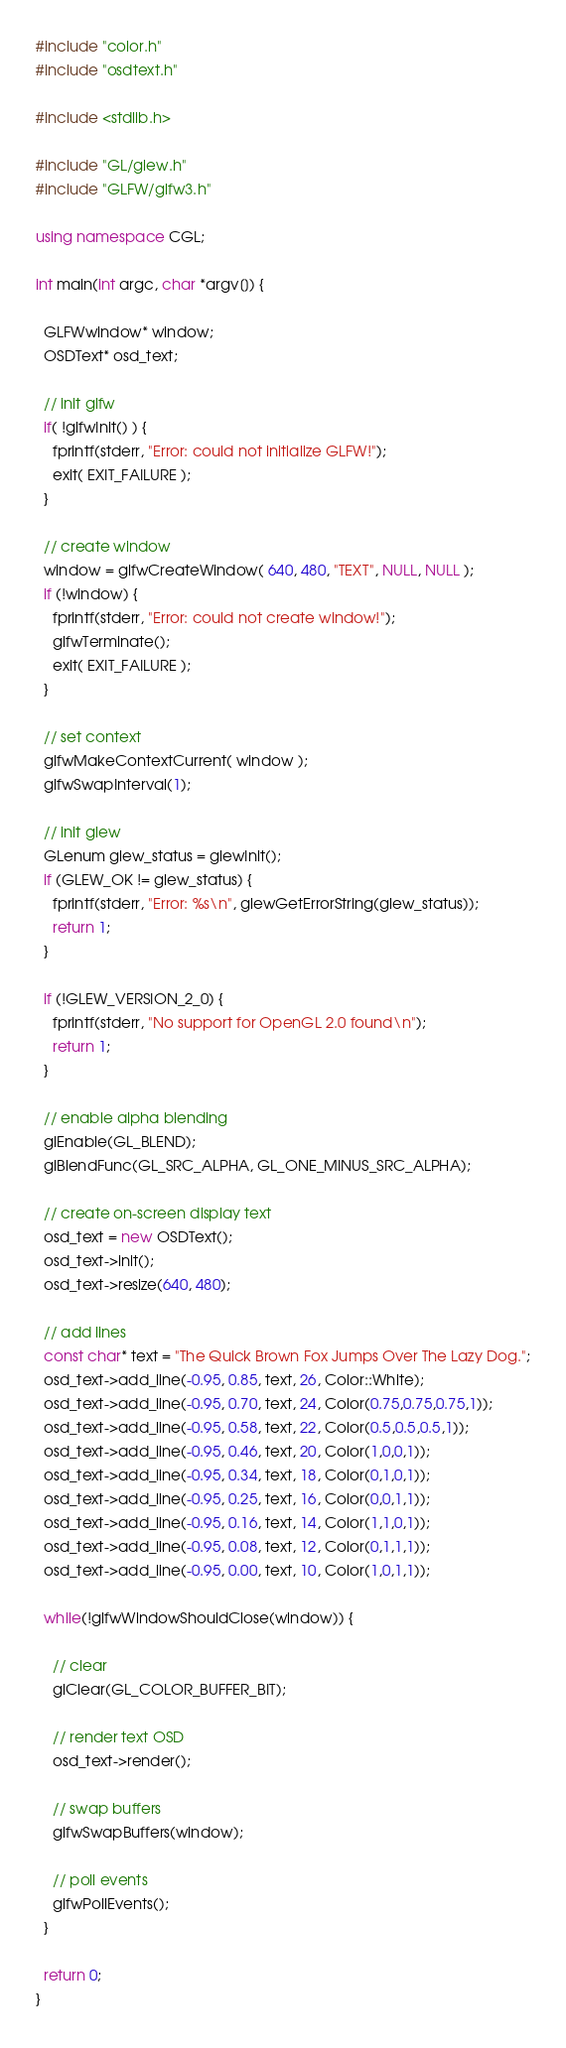<code> <loc_0><loc_0><loc_500><loc_500><_C++_>#include "color.h"
#include "osdtext.h"

#include <stdlib.h>

#include "GL/glew.h"
#include "GLFW/glfw3.h"

using namespace CGL;

int main(int argc, char *argv[]) {

  GLFWwindow* window;
  OSDText* osd_text;

  // init glfw
  if( !glfwInit() ) {
    fprintf(stderr, "Error: could not initialize GLFW!");
    exit( EXIT_FAILURE );
  }

  // create window
  window = glfwCreateWindow( 640, 480, "TEXT", NULL, NULL );
  if (!window) {
    fprintf(stderr, "Error: could not create window!");
    glfwTerminate();
    exit( EXIT_FAILURE );
  }

  // set context
  glfwMakeContextCurrent( window );
  glfwSwapInterval(1);

  // init glew
  GLenum glew_status = glewInit();
  if (GLEW_OK != glew_status) {
    fprintf(stderr, "Error: %s\n", glewGetErrorString(glew_status));
    return 1;
  }

  if (!GLEW_VERSION_2_0) {
    fprintf(stderr, "No support for OpenGL 2.0 found\n");
    return 1;
  }

  // enable alpha blending
  glEnable(GL_BLEND);
  glBlendFunc(GL_SRC_ALPHA, GL_ONE_MINUS_SRC_ALPHA);

  // create on-screen display text
  osd_text = new OSDText();
  osd_text->init();
  osd_text->resize(640, 480);

  // add lines
  const char* text = "The Quick Brown Fox Jumps Over The Lazy Dog.";
  osd_text->add_line(-0.95, 0.85, text, 26, Color::White);
  osd_text->add_line(-0.95, 0.70, text, 24, Color(0.75,0.75,0.75,1));
  osd_text->add_line(-0.95, 0.58, text, 22, Color(0.5,0.5,0.5,1));
  osd_text->add_line(-0.95, 0.46, text, 20, Color(1,0,0,1));
  osd_text->add_line(-0.95, 0.34, text, 18, Color(0,1,0,1));
  osd_text->add_line(-0.95, 0.25, text, 16, Color(0,0,1,1));
  osd_text->add_line(-0.95, 0.16, text, 14, Color(1,1,0,1));
  osd_text->add_line(-0.95, 0.08, text, 12, Color(0,1,1,1));
  osd_text->add_line(-0.95, 0.00, text, 10, Color(1,0,1,1));

  while(!glfwWindowShouldClose(window)) {

    // clear
    glClear(GL_COLOR_BUFFER_BIT);

    // render text OSD
    osd_text->render();

    // swap buffers
    glfwSwapBuffers(window);

    // poll events
    glfwPollEvents();
  }

  return 0;
}
</code> 